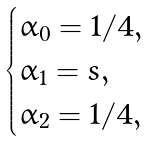<formula> <loc_0><loc_0><loc_500><loc_500>\begin{cases} \alpha _ { 0 } = 1 / 4 , \\ \alpha _ { 1 } = s , \\ \alpha _ { 2 } = 1 / 4 , \end{cases}</formula> 